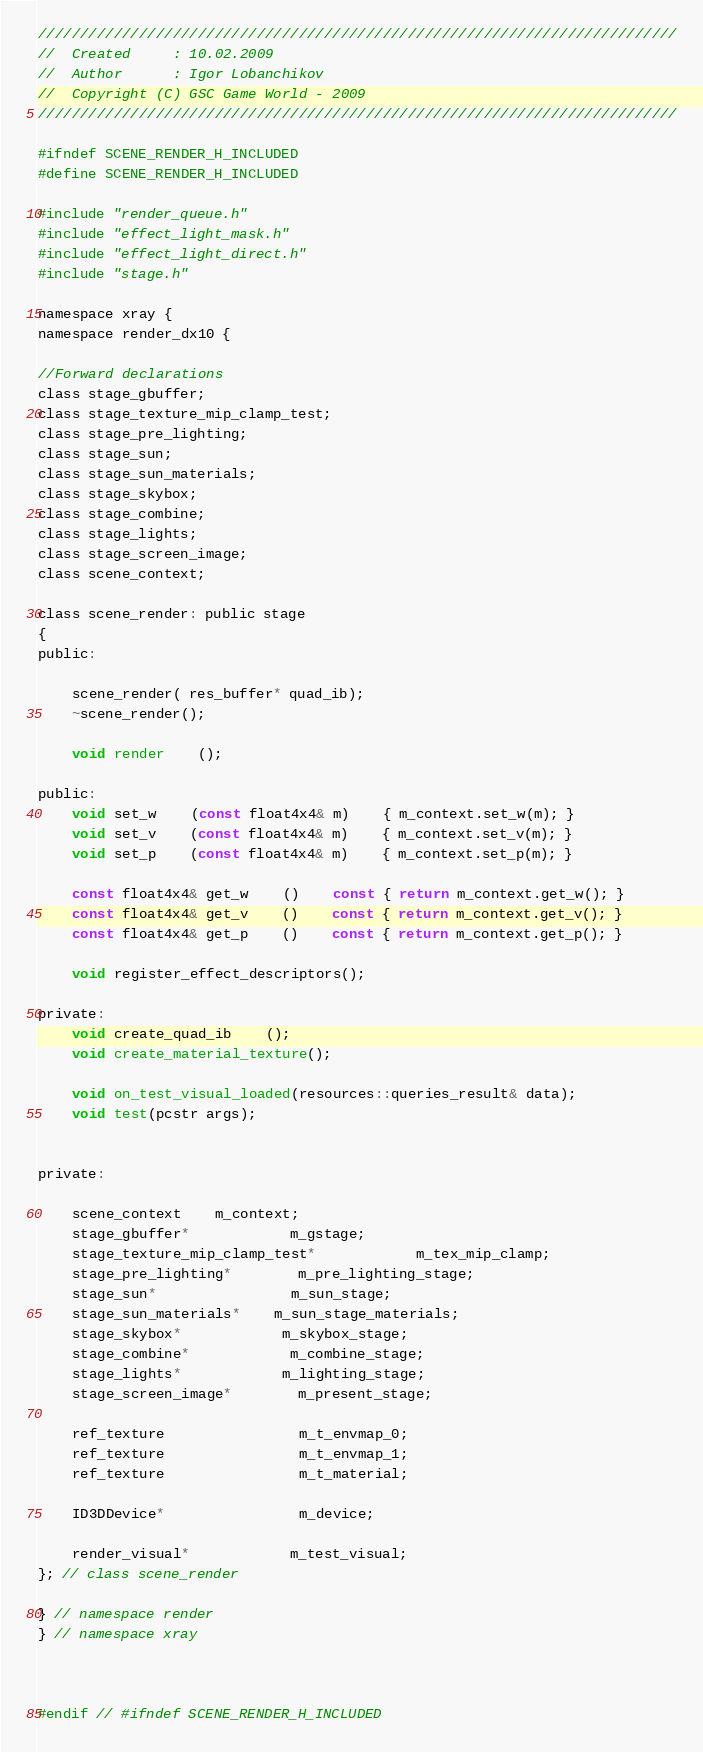<code> <loc_0><loc_0><loc_500><loc_500><_C_>////////////////////////////////////////////////////////////////////////////
//	Created		: 10.02.2009
//	Author		: Igor Lobanchikov
//	Copyright (C) GSC Game World - 2009
////////////////////////////////////////////////////////////////////////////

#ifndef SCENE_RENDER_H_INCLUDED
#define SCENE_RENDER_H_INCLUDED

#include "render_queue.h"
#include "effect_light_mask.h"
#include "effect_light_direct.h"
#include "stage.h"

namespace xray {
namespace render_dx10 {

//Forward declarations
class stage_gbuffer;
class stage_texture_mip_clamp_test;
class stage_pre_lighting;
class stage_sun;
class stage_sun_materials;
class stage_skybox;
class stage_combine;
class stage_lights;
class stage_screen_image;
class scene_context;

class scene_render: public stage
{
public:

	scene_render( res_buffer* quad_ib);
	~scene_render();

	void render	();

public:
	void set_w	(const float4x4& m)	{ m_context.set_w(m); }
	void set_v	(const float4x4& m)	{ m_context.set_v(m); }
	void set_p	(const float4x4& m)	{ m_context.set_p(m); }

	const float4x4& get_w	()	const { return m_context.get_w(); }
	const float4x4& get_v	()	const { return m_context.get_v(); }
	const float4x4& get_p	()	const { return m_context.get_p(); }

	void register_effect_descriptors();

private:
	void create_quad_ib	();
	void create_material_texture();

	void on_test_visual_loaded(resources::queries_result& data);
	void test(pcstr args);

	
private:

	scene_context	m_context;
	stage_gbuffer*			m_gstage;
	stage_texture_mip_clamp_test*			m_tex_mip_clamp;
	stage_pre_lighting*		m_pre_lighting_stage;
	stage_sun*				m_sun_stage;
	stage_sun_materials*	m_sun_stage_materials;
	stage_skybox*			m_skybox_stage;
	stage_combine*			m_combine_stage;
	stage_lights*			m_lighting_stage;
	stage_screen_image*		m_present_stage;

	ref_texture				m_t_envmap_0;
	ref_texture				m_t_envmap_1;
	ref_texture				m_t_material;

	ID3DDevice*				m_device;

	render_visual*			m_test_visual;
}; // class scene_render

} // namespace render 
} // namespace xray 



#endif // #ifndef SCENE_RENDER_H_INCLUDED</code> 